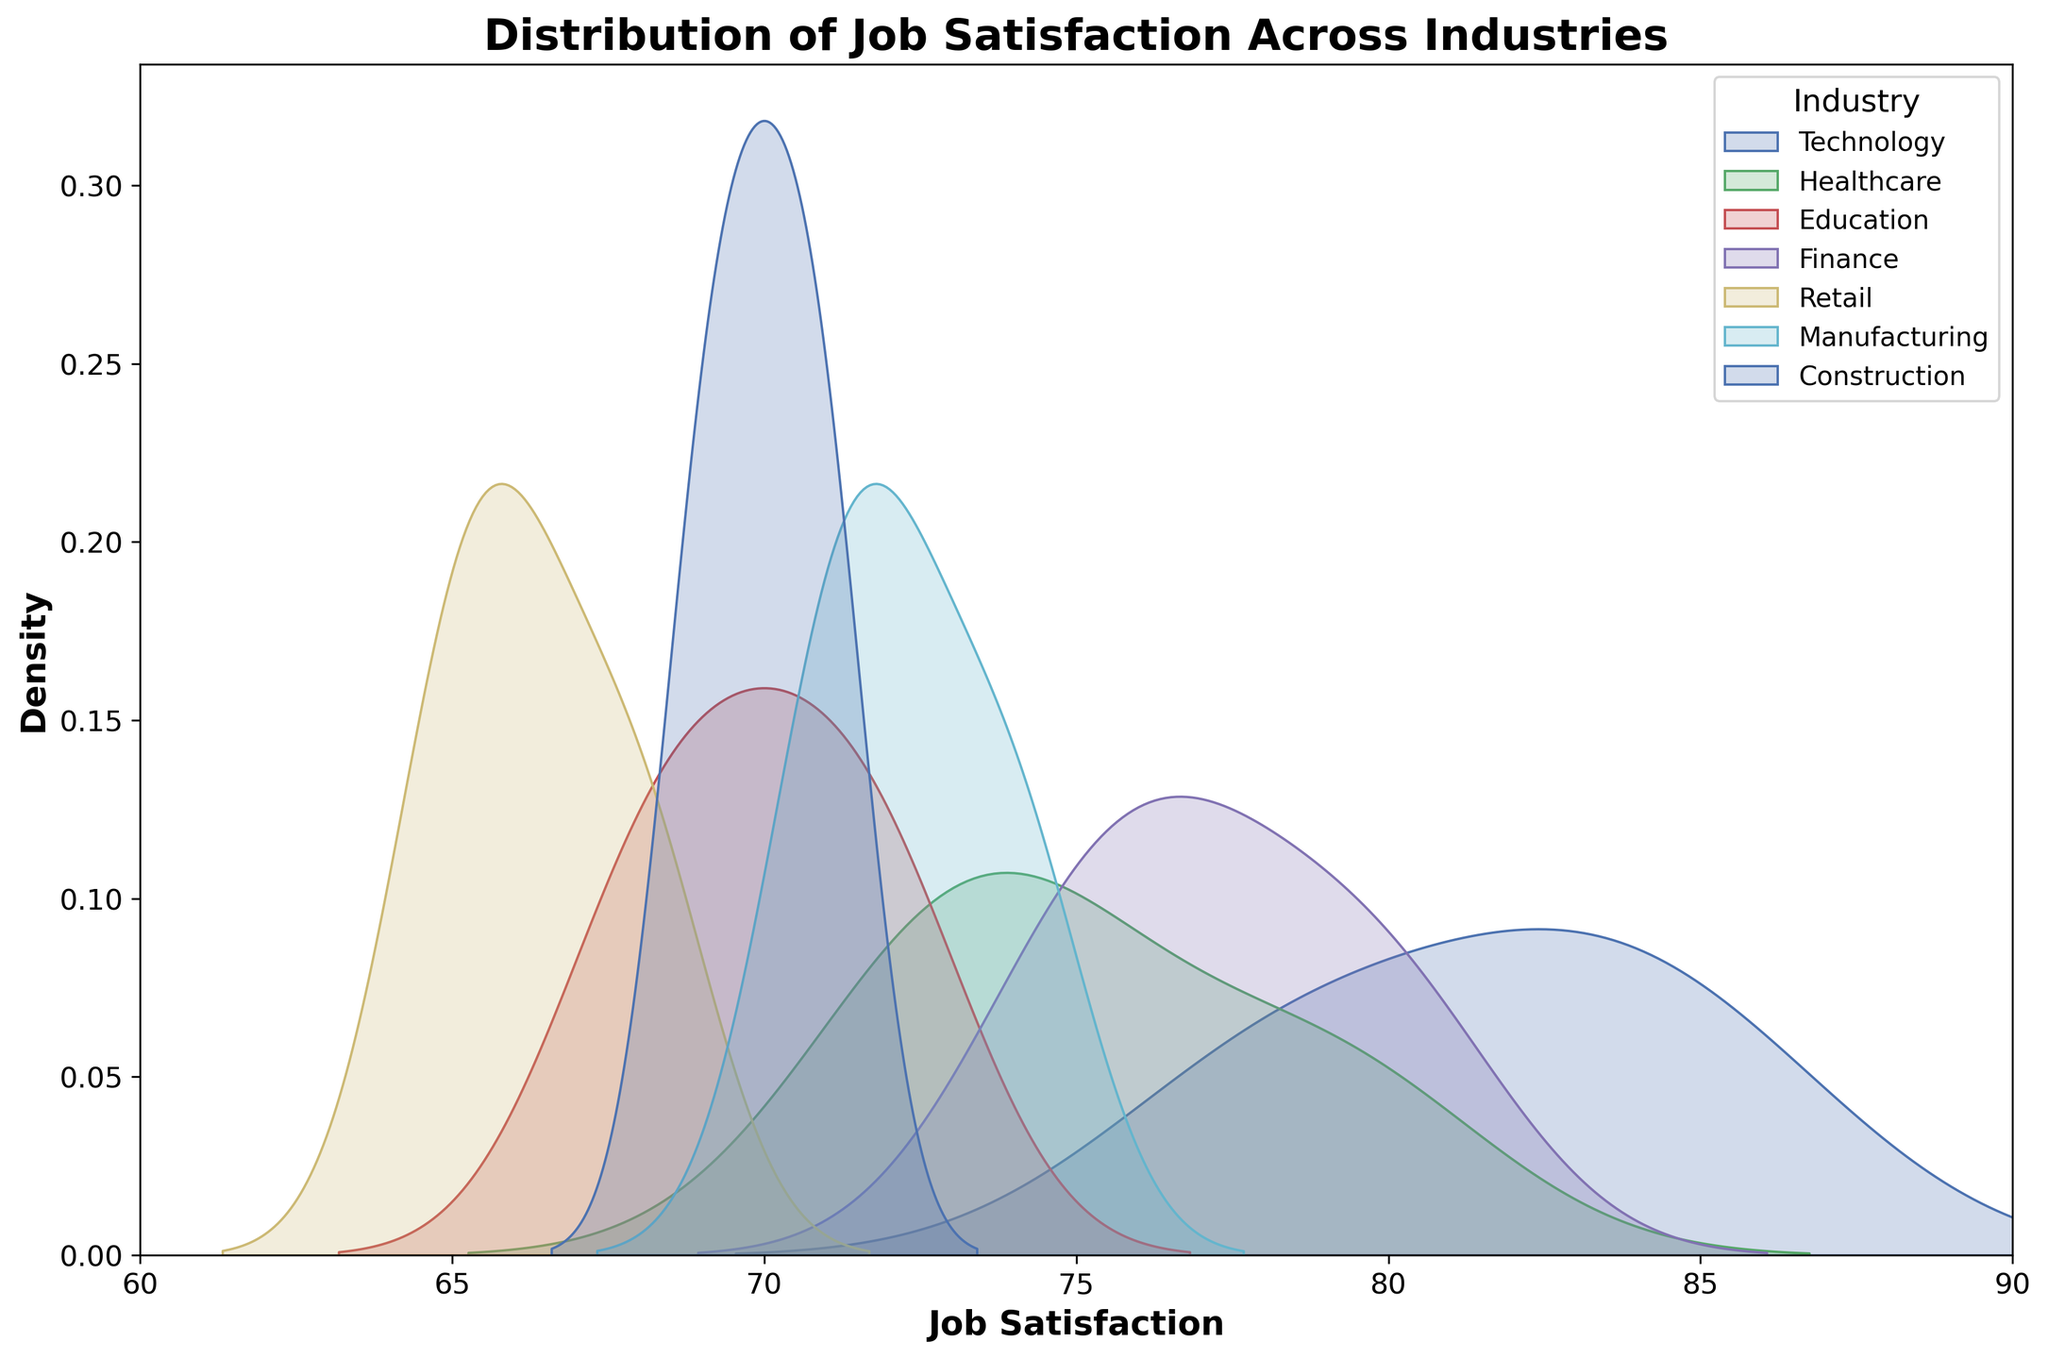What is the title of the distplot? The title is displayed at the top of the distplot figure. It reads "Distribution of Job Satisfaction Across Industries".
Answer: Distribution of Job Satisfaction Across Industries Which industry shows the highest peak in job satisfaction density? By looking at the density curves, the industry with the highest peak indicates the highest job satisfaction density. The technology sector shows the highest peak.
Answer: Technology What is the range of the x-axis in the distplot? The x-axis represents job satisfaction levels, ranging from 60 to 90 as labeled on the axis.
Answer: 60 to 90 How many industries are represented in the distplot? Each density curve represents an industry. By counting the legend items, you can see that there are six industries: Technology, Healthcare, Education, Finance, Retail, and Manufacturing.
Answer: 6 Which industry has the broadest spread of job satisfaction levels? The broadest spread is assessed by examining the width of the density curve. The construction industry's density curve appears to spread widely across job satisfaction levels.
Answer: Construction How does job satisfaction in Retail compare to that in Healthcare? By comparing the density peaks and shapes, the retail industry's job satisfaction is generally lower than in the healthcare sector. The retail curve peaks at a lower job satisfaction level than healthcare.
Answer: Lower Which two industries have similar job satisfaction distributions? Similar distributions can be identified if their density curves overlap significantly. Education and Construction have similar job satisfaction distributions, as their curves overlap and follow a similar shape.
Answer: Education and Construction What is the approximate job satisfaction level where Technology and Finance densities intersect? The intersection point can be identified visually where the Technology and Finance density curves cross each other on the x-axis, around a job satisfaction level of ~78.
Answer: ~78 Which industry has the lowest job satisfaction peak? The industry with the lowest peak is assessed by looking for the smallest maximum density. Retail has the lowest peak density among the industries.
Answer: Retail 